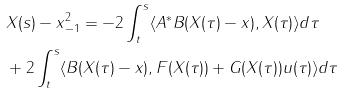<formula> <loc_0><loc_0><loc_500><loc_500>& \| X ( s ) - x \| _ { - 1 } ^ { 2 } = - 2 \int _ { t } ^ { s } \langle A ^ { * } B ( X ( \tau ) - x ) , X ( \tau ) \rangle d \tau \\ & + 2 \int _ { t } ^ { s } \langle B ( X ( \tau ) - x ) , F ( X ( \tau ) ) + G ( X ( \tau ) ) u ( \tau ) \rangle d \tau</formula> 